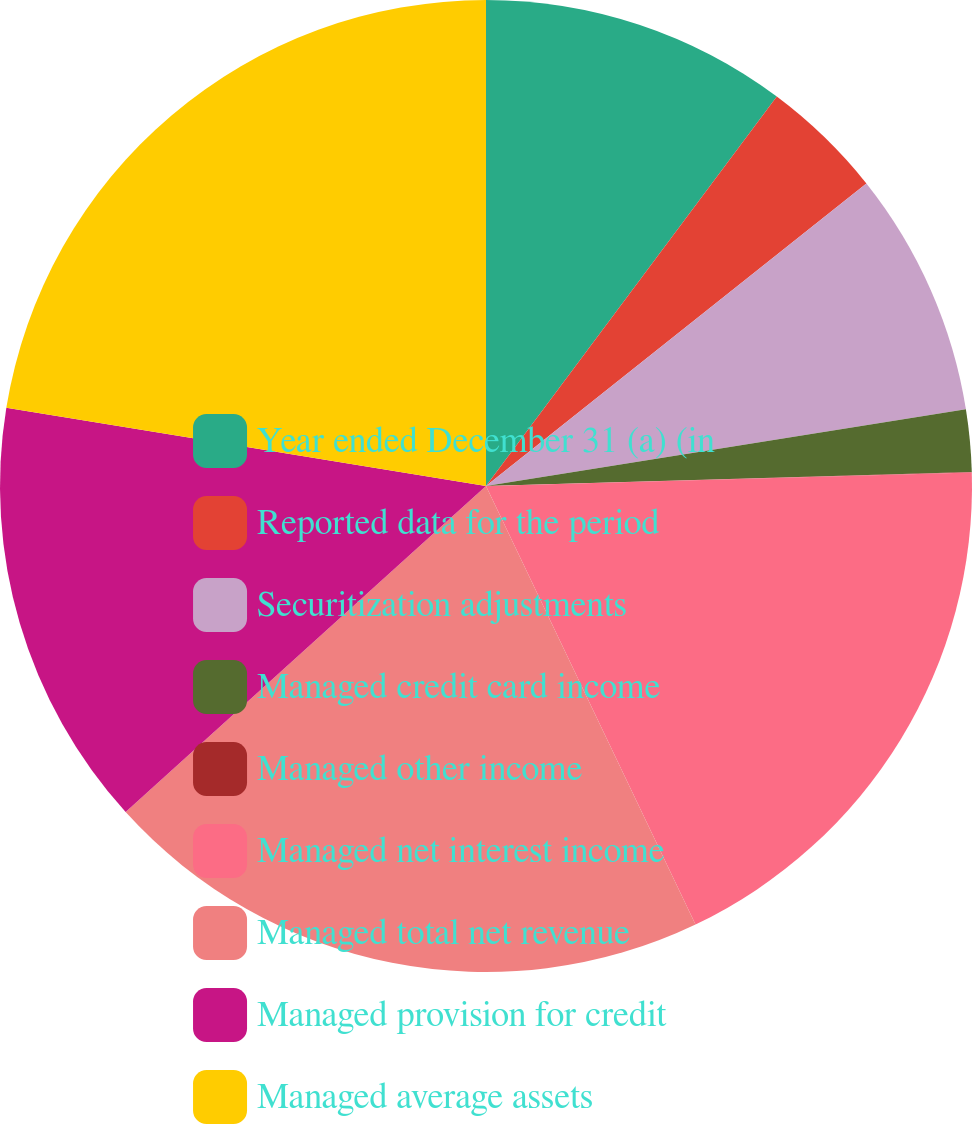Convert chart. <chart><loc_0><loc_0><loc_500><loc_500><pie_chart><fcel>Year ended December 31 (a) (in<fcel>Reported data for the period<fcel>Securitization adjustments<fcel>Managed credit card income<fcel>Managed other income<fcel>Managed net interest income<fcel>Managed total net revenue<fcel>Managed provision for credit<fcel>Managed average assets<nl><fcel>10.21%<fcel>4.1%<fcel>8.17%<fcel>2.06%<fcel>0.02%<fcel>18.35%<fcel>20.39%<fcel>14.28%<fcel>22.43%<nl></chart> 